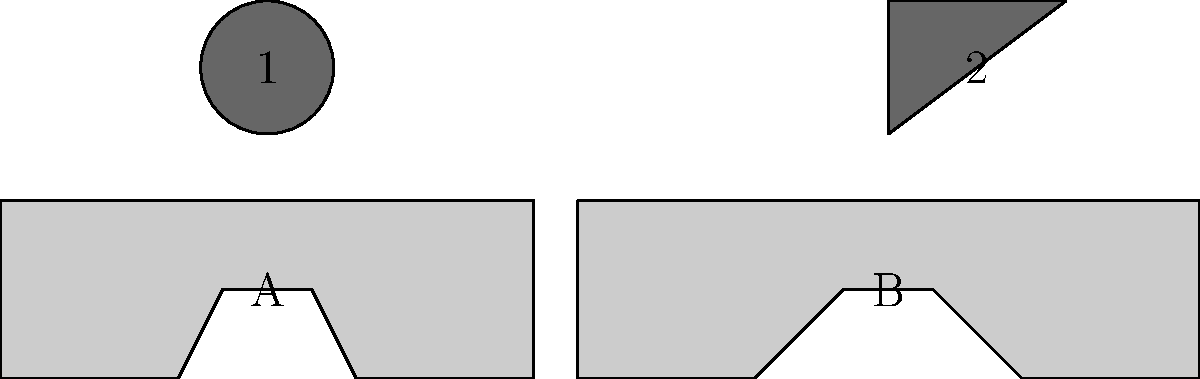Match the electric vehicle logos (1 and 2) with their corresponding car silhouettes (A and B). To match the electric vehicle logos with their corresponding car silhouettes, we need to consider the following steps:

1. Observe the shapes of the logos:
   - Logo 1 is a circle
   - Logo 2 is a triangle

2. Look at the car silhouettes:
   - Car A has a more rounded shape, typical of compact electric vehicles
   - Car B has a more angular and aggressive shape, often associated with sportier electric vehicles

3. Consider common electric vehicle brands:
   - Circular logos are often associated with brands like Tesla or Nissan
   - Triangular logos are more commonly used by performance-oriented brands like Polestar

4. Match the logos to the car shapes:
   - The circular logo (1) fits better with the compact, rounded silhouette of Car A
   - The triangular logo (2) aligns more with the sportier, angular silhouette of Car B

5. Make the final connections:
   - Logo 1 matches with Car A
   - Logo 2 matches with Car B
Answer: 1-A, 2-B 